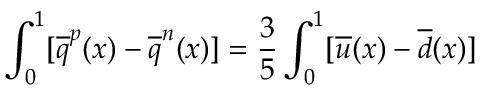<formula> <loc_0><loc_0><loc_500><loc_500>\int _ { 0 } ^ { 1 } [ \overline { q } ^ { p } ( x ) - \overline { q } ^ { n } ( x ) ] = \frac { 3 } { 5 } \int _ { 0 } ^ { 1 } [ \overline { u } ( x ) - \overline { d } ( x ) ]</formula> 